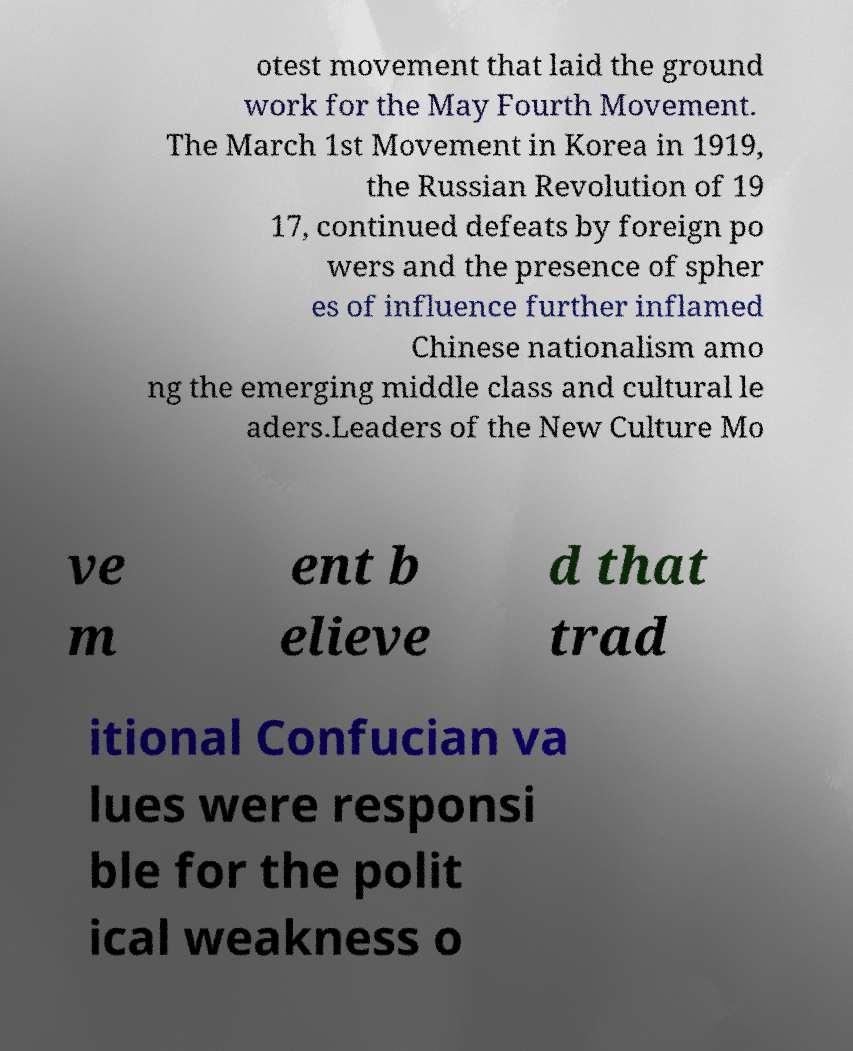There's text embedded in this image that I need extracted. Can you transcribe it verbatim? otest movement that laid the ground work for the May Fourth Movement. The March 1st Movement in Korea in 1919, the Russian Revolution of 19 17, continued defeats by foreign po wers and the presence of spher es of influence further inflamed Chinese nationalism amo ng the emerging middle class and cultural le aders.Leaders of the New Culture Mo ve m ent b elieve d that trad itional Confucian va lues were responsi ble for the polit ical weakness o 